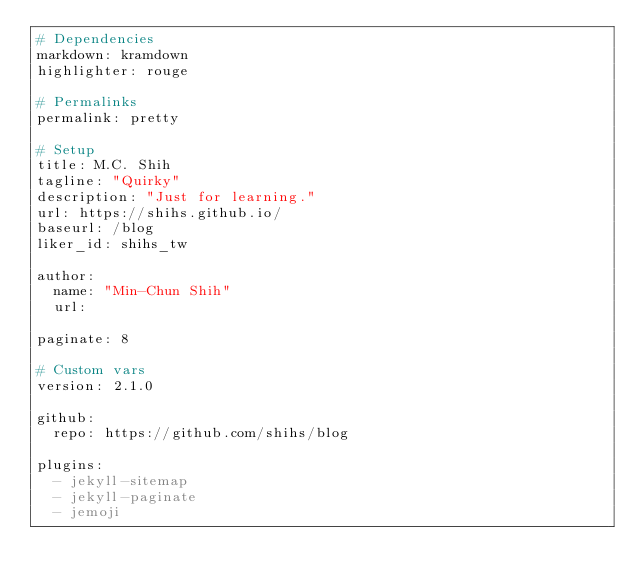<code> <loc_0><loc_0><loc_500><loc_500><_YAML_># Dependencies
markdown: kramdown
highlighter: rouge

# Permalinks
permalink: pretty

# Setup
title: M.C. Shih
tagline: "Quirky"
description: "Just for learning."
url: https://shihs.github.io/
baseurl: /blog
liker_id: shihs_tw

author:
  name: "Min-Chun Shih"
  url:

paginate: 8

# Custom vars
version: 2.1.0

github:
  repo: https://github.com/shihs/blog

plugins:
  - jekyll-sitemap
  - jekyll-paginate
  - jemoji
</code> 